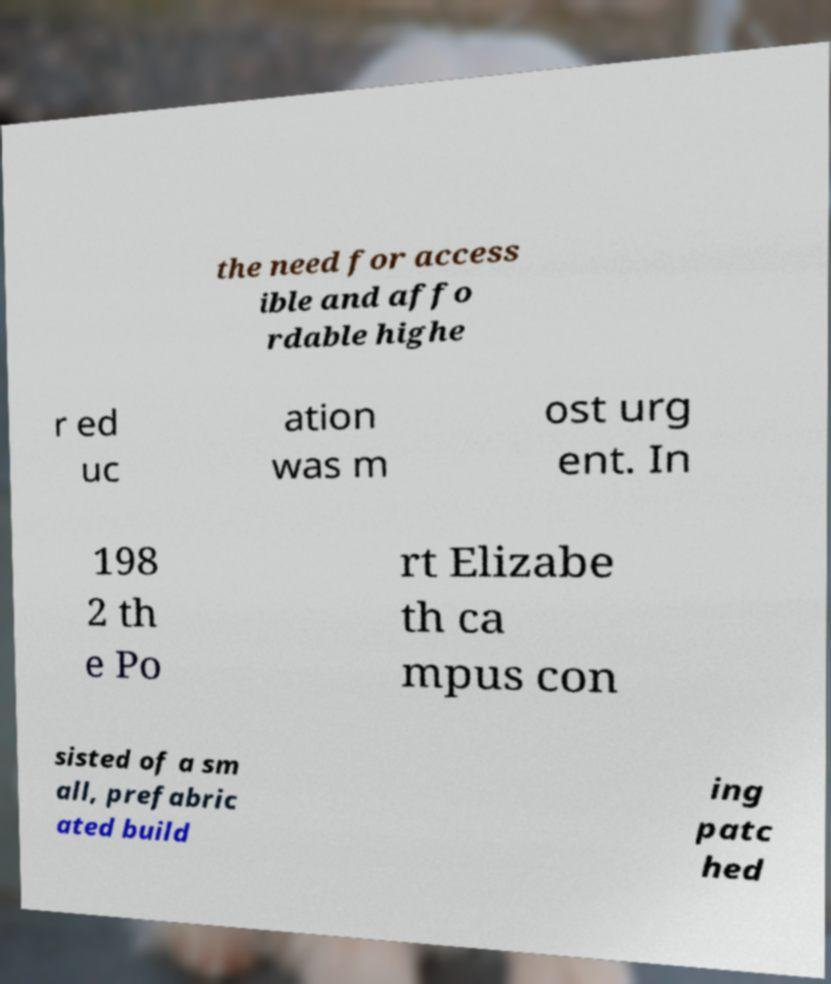Can you accurately transcribe the text from the provided image for me? the need for access ible and affo rdable highe r ed uc ation was m ost urg ent. In 198 2 th e Po rt Elizabe th ca mpus con sisted of a sm all, prefabric ated build ing patc hed 